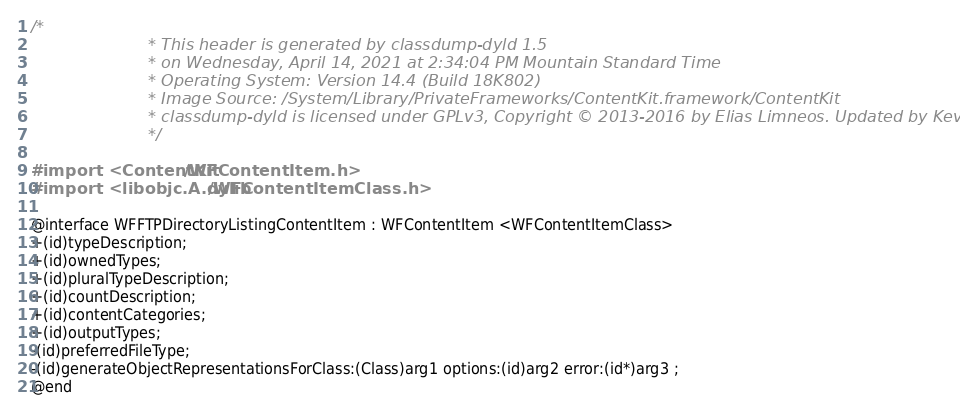Convert code to text. <code><loc_0><loc_0><loc_500><loc_500><_C_>/*
                       * This header is generated by classdump-dyld 1.5
                       * on Wednesday, April 14, 2021 at 2:34:04 PM Mountain Standard Time
                       * Operating System: Version 14.4 (Build 18K802)
                       * Image Source: /System/Library/PrivateFrameworks/ContentKit.framework/ContentKit
                       * classdump-dyld is licensed under GPLv3, Copyright © 2013-2016 by Elias Limneos. Updated by Kevin Bradley.
                       */

#import <ContentKit/WFContentItem.h>
#import <libobjc.A.dylib/WFContentItemClass.h>

@interface WFFTPDirectoryListingContentItem : WFContentItem <WFContentItemClass>
+(id)typeDescription;
+(id)ownedTypes;
+(id)pluralTypeDescription;
+(id)countDescription;
+(id)contentCategories;
+(id)outputTypes;
-(id)preferredFileType;
-(id)generateObjectRepresentationsForClass:(Class)arg1 options:(id)arg2 error:(id*)arg3 ;
@end

</code> 